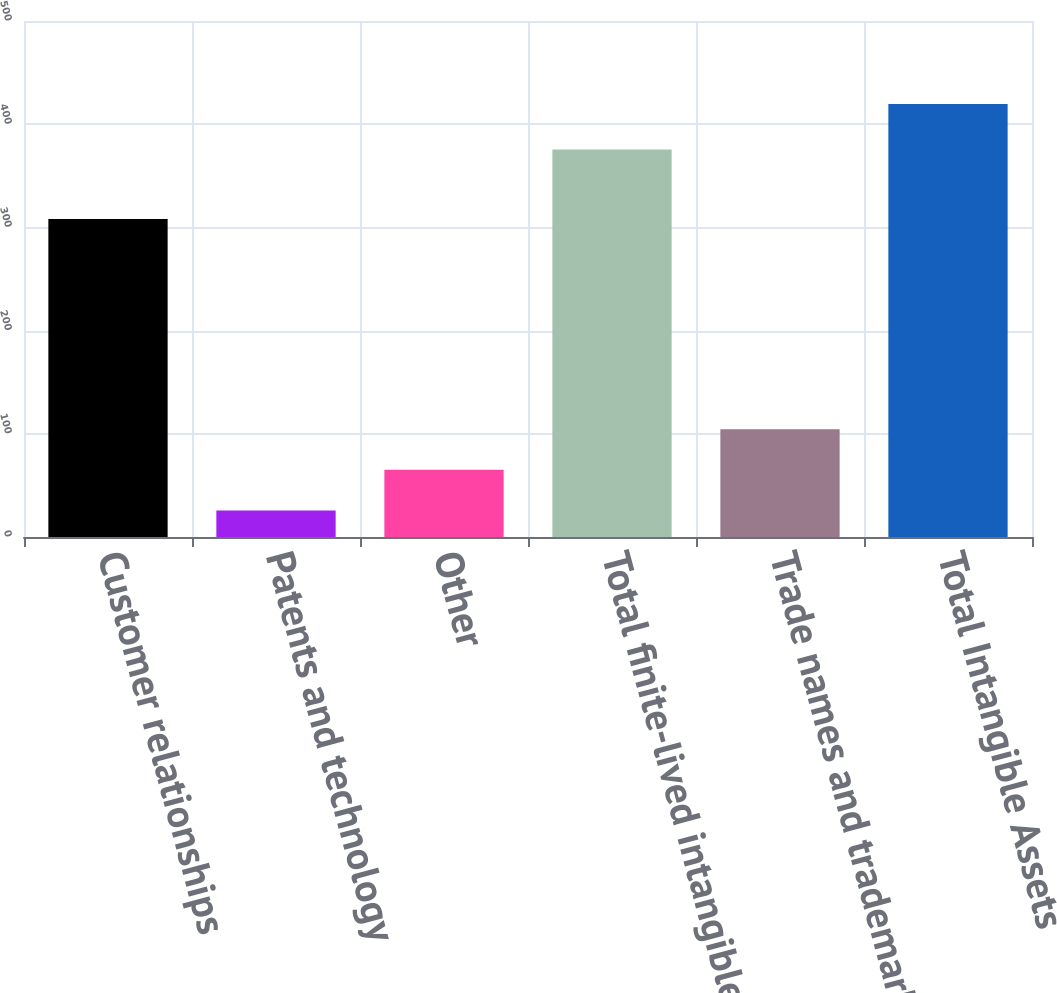Convert chart. <chart><loc_0><loc_0><loc_500><loc_500><bar_chart><fcel>Customer relationships<fcel>Patents and technology<fcel>Other<fcel>Total finite-lived intangibles<fcel>Trade names and trademarks<fcel>Total Intangible Assets<nl><fcel>308.1<fcel>25.7<fcel>65.08<fcel>375.4<fcel>104.46<fcel>419.5<nl></chart> 